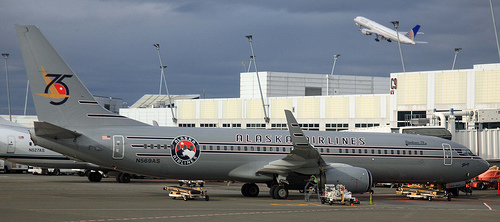Could this place be the train station? No, the setting clearly showcases an airplane on a tarmac, characteristic of an airport, not a train station. 